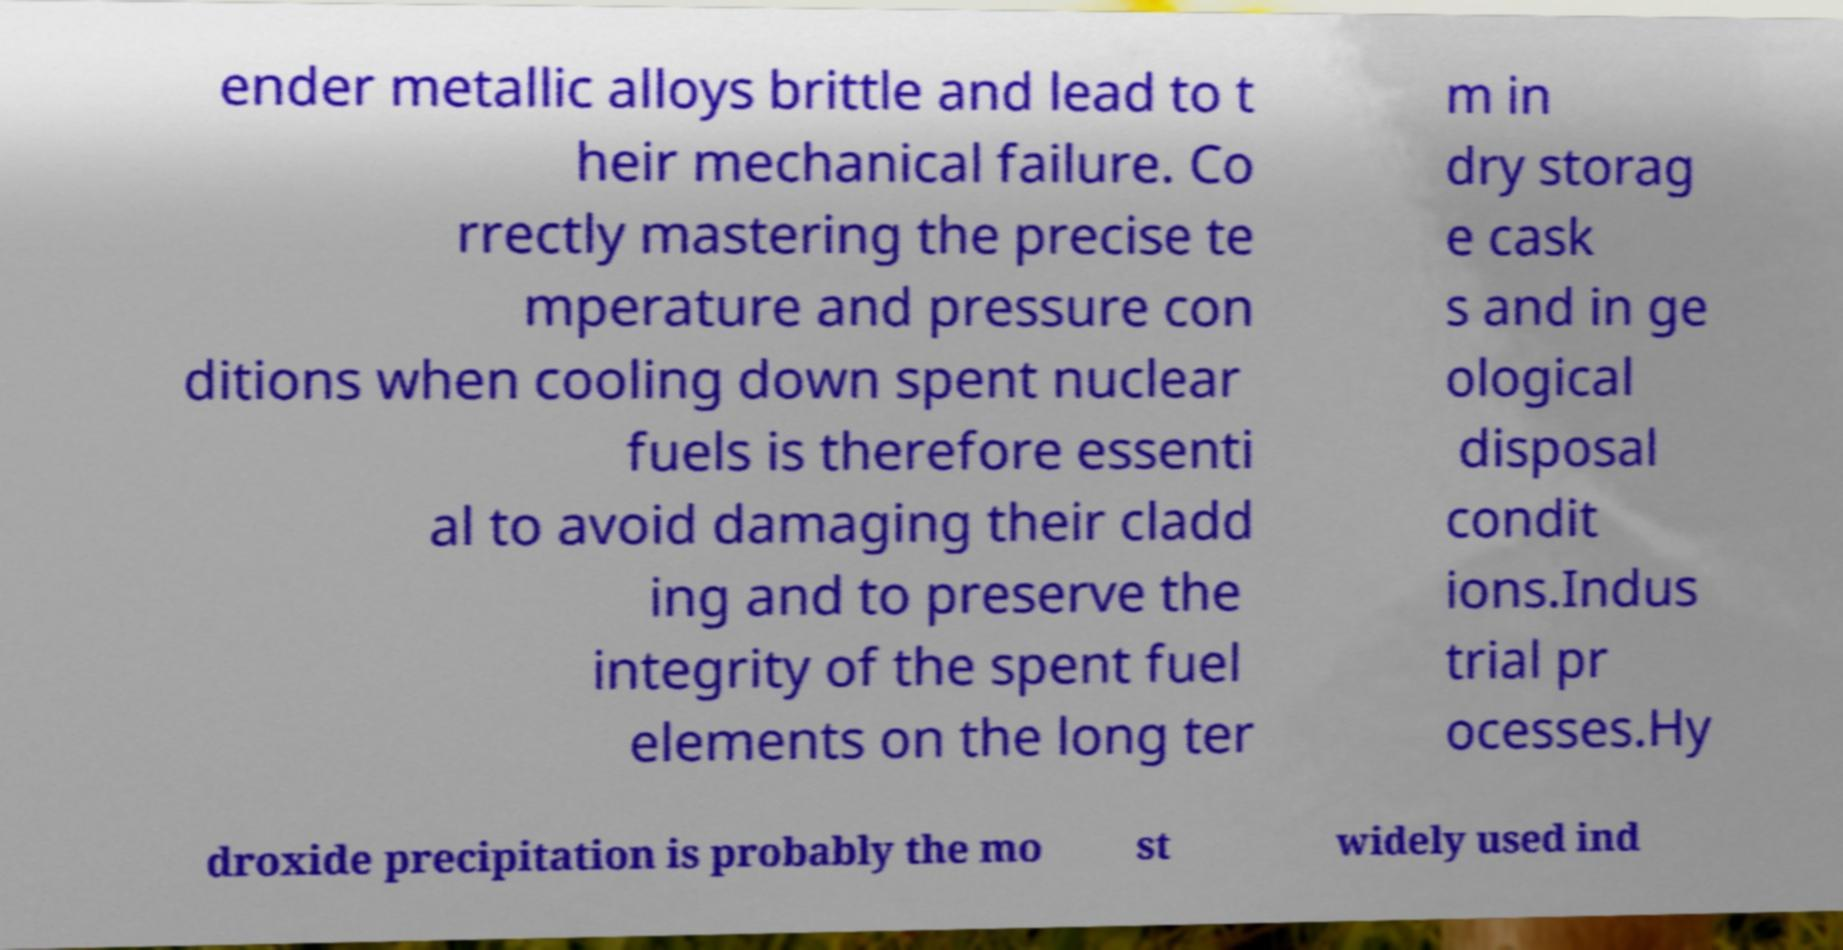There's text embedded in this image that I need extracted. Can you transcribe it verbatim? ender metallic alloys brittle and lead to t heir mechanical failure. Co rrectly mastering the precise te mperature and pressure con ditions when cooling down spent nuclear fuels is therefore essenti al to avoid damaging their cladd ing and to preserve the integrity of the spent fuel elements on the long ter m in dry storag e cask s and in ge ological disposal condit ions.Indus trial pr ocesses.Hy droxide precipitation is probably the mo st widely used ind 